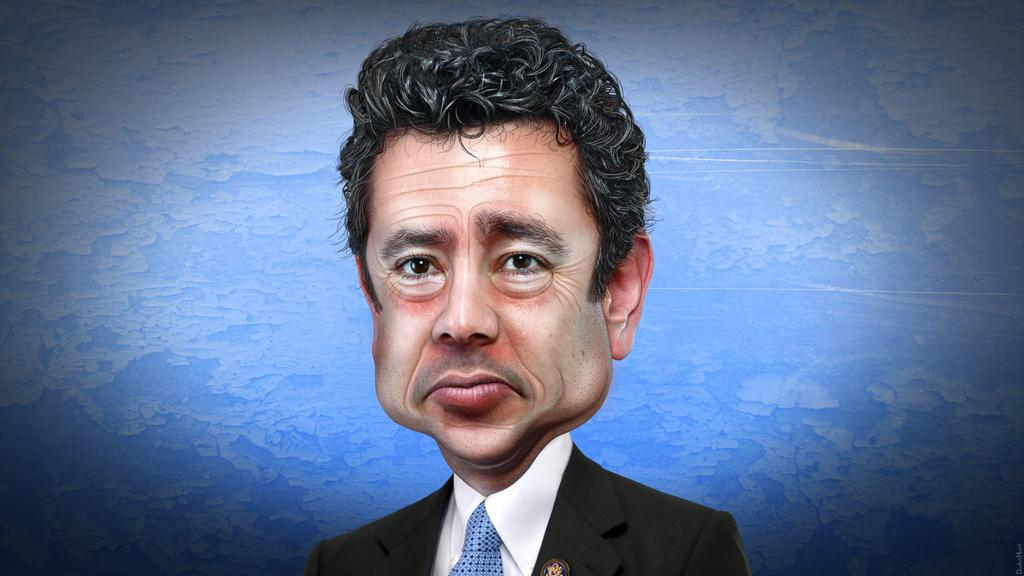Who is present in the image? There is a man in the image. What is the man wearing? The man is wearing a blazer and a tie. What color is the background of the image? The background of the image is blue. What type of rabbit can be seen in the caption of the image? There is no rabbit or caption present in the image. 